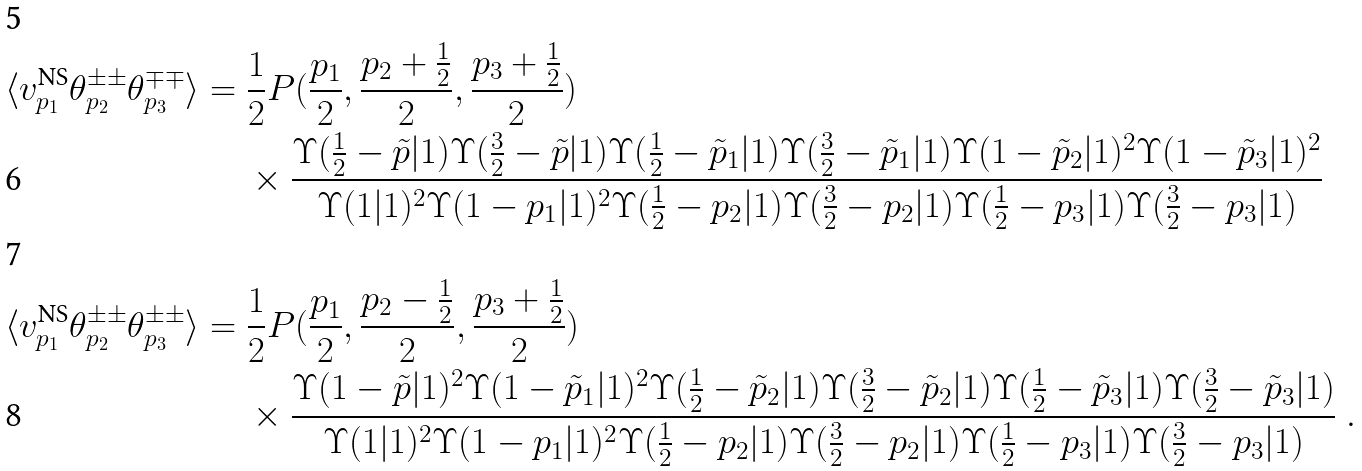<formula> <loc_0><loc_0><loc_500><loc_500>\langle v ^ { \text {NS} } _ { p _ { 1 } } \theta ^ { \pm \pm } _ { p _ { 2 } } \theta ^ { \mp \mp } _ { p _ { 3 } } \rangle & = \frac { 1 } { 2 } P ( \frac { p _ { 1 } } { 2 } , \frac { p _ { 2 } + \frac { 1 } { 2 } } { 2 } , \frac { p _ { 3 } + \frac { 1 } { 2 } } { 2 } ) \\ & \quad \ \times \frac { \Upsilon ( \frac { 1 } { 2 } - \tilde { p } | 1 ) \Upsilon ( \frac { 3 } { 2 } - \tilde { p } | 1 ) \Upsilon ( \frac { 1 } { 2 } - \tilde { p } _ { 1 } | 1 ) \Upsilon ( \frac { 3 } { 2 } - \tilde { p } _ { 1 } | 1 ) \Upsilon ( 1 - \tilde { p } _ { 2 } | 1 ) ^ { 2 } \Upsilon ( 1 - \tilde { p } _ { 3 } | 1 ) ^ { 2 } } { \Upsilon ( 1 | 1 ) ^ { 2 } \Upsilon ( 1 - p _ { 1 } | 1 ) ^ { 2 } \Upsilon ( \frac { 1 } { 2 } - p _ { 2 } | 1 ) \Upsilon ( \frac { 3 } { 2 } - p _ { 2 } | 1 ) \Upsilon ( \frac { 1 } { 2 } - p _ { 3 } | 1 ) \Upsilon ( \frac { 3 } { 2 } - p _ { 3 } | 1 ) } \\ \langle v ^ { \text {NS} } _ { p _ { 1 } } \theta ^ { \pm \pm } _ { p _ { 2 } } \theta ^ { \pm \pm } _ { p _ { 3 } } \rangle & = \frac { 1 } { 2 } P ( \frac { p _ { 1 } } { 2 } , \frac { p _ { 2 } - \frac { 1 } { 2 } } { 2 } , \frac { p _ { 3 } + \frac { 1 } { 2 } } { 2 } ) \\ & \quad \ \times \frac { \Upsilon ( 1 - \tilde { p } | 1 ) ^ { 2 } \Upsilon ( 1 - \tilde { p } _ { 1 } | 1 ) ^ { 2 } \Upsilon ( \frac { 1 } { 2 } - \tilde { p } _ { 2 } | 1 ) \Upsilon ( \frac { 3 } { 2 } - \tilde { p } _ { 2 } | 1 ) \Upsilon ( \frac { 1 } { 2 } - \tilde { p } _ { 3 } | 1 ) \Upsilon ( \frac { 3 } { 2 } - \tilde { p } _ { 3 } | 1 ) } { \Upsilon ( 1 | 1 ) ^ { 2 } \Upsilon ( 1 - p _ { 1 } | 1 ) ^ { 2 } \Upsilon ( \frac { 1 } { 2 } - p _ { 2 } | 1 ) \Upsilon ( \frac { 3 } { 2 } - p _ { 2 } | 1 ) \Upsilon ( \frac { 1 } { 2 } - p _ { 3 } | 1 ) \Upsilon ( \frac { 3 } { 2 } - p _ { 3 } | 1 ) } \ .</formula> 